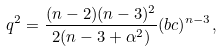Convert formula to latex. <formula><loc_0><loc_0><loc_500><loc_500>q ^ { 2 } = \frac { ( n - 2 ) ( n - 3 ) ^ { 2 } } { 2 ( n - 3 + \alpha ^ { 2 } ) } ( b c ) ^ { n - 3 } ,</formula> 